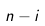<formula> <loc_0><loc_0><loc_500><loc_500>n - i</formula> 